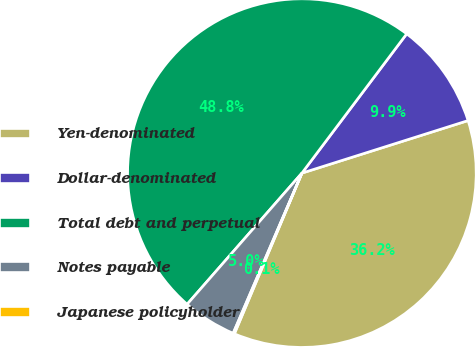Convert chart. <chart><loc_0><loc_0><loc_500><loc_500><pie_chart><fcel>Yen-denominated<fcel>Dollar-denominated<fcel>Total debt and perpetual<fcel>Notes payable<fcel>Japanese policyholder<nl><fcel>36.21%<fcel>9.86%<fcel>48.83%<fcel>4.99%<fcel>0.12%<nl></chart> 